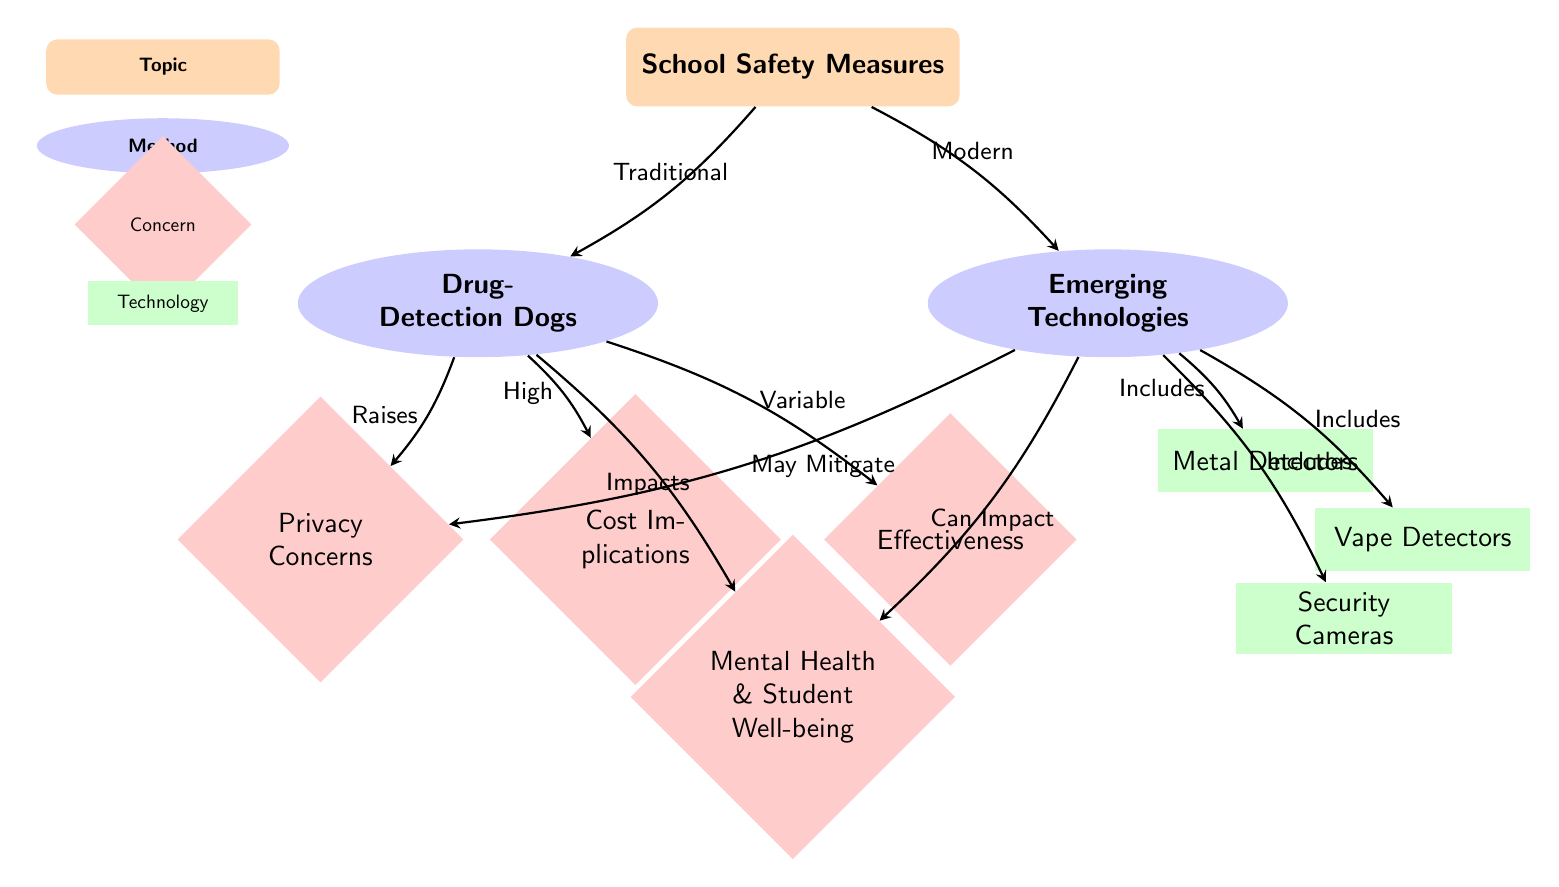What are the two methods of school safety measures displayed? The diagram identifies two methods of school safety measures: 'Drug-Detection Dogs' and 'Emerging Technologies.' These are the main categories highlighted in the diagram, positioned under the topic of 'School Safety Measures.'
Answer: Drug-Detection Dogs, Emerging Technologies What is one of the concerns raised by using Drug-Detection Dogs? The diagram shows that Drug-Detection Dogs raise 'Privacy Concerns.' This node is linked to Drug-Detection Dogs, indicating the negative implication associated with this method.
Answer: Privacy Concerns Which technology is included under Emerging Technologies? The diagram lists several technologies included under Emerging Technologies. One specific technology mentioned is 'Vape Detectors.' This is one of the methods categorized under Emerging Technologies in the diagram.
Answer: Vape Detectors What impact do both Drug-Detection Dogs and Emerging Technologies have on student mental health? Both methods are shown to have an impact on student mental health and well-being. Drug-Detection Dogs are indicated to 'Impacts' mental health while Emerging Technologies 'Can Impact' it, suggesting that both can have effects on this concern.
Answer: Impacts, Can Impact How many concerns are connected to Drug-Detection Dogs in the diagram? There are three concerns connected to Drug-Detection Dogs in the diagram: 'Privacy Concerns,' 'Cost Implications,' and 'Effectiveness.' This is detailed through the visual connections from Drug-Detection Dogs to each of these concern nodes.
Answer: Three How does Emerging Technologies relate to Privacy Concerns? The diagram suggests that Emerging Technologies may help to 'May Mitigate' Privacy Concerns. This connection indicates that while there are considerations for privacy, the use of these newer technologies might address or lessen those concerns compared to traditional methods.
Answer: May Mitigate Which safety measure has a variable effectiveness? The diagram indicates that the effectiveness of Drug-Detection Dogs is 'Variable.' This term shows that their effectiveness is not consistent and may vary in different situations.
Answer: Variable How many technologies are included under the Emerging Technologies category? The diagram includes three specific technologies under the Emerging Technologies category: 'Metal Detectors,' 'Vape Detectors,' and 'Security Cameras.' These are clearly listed, demonstrating the variety of technologies considered as alternatives.
Answer: Three 